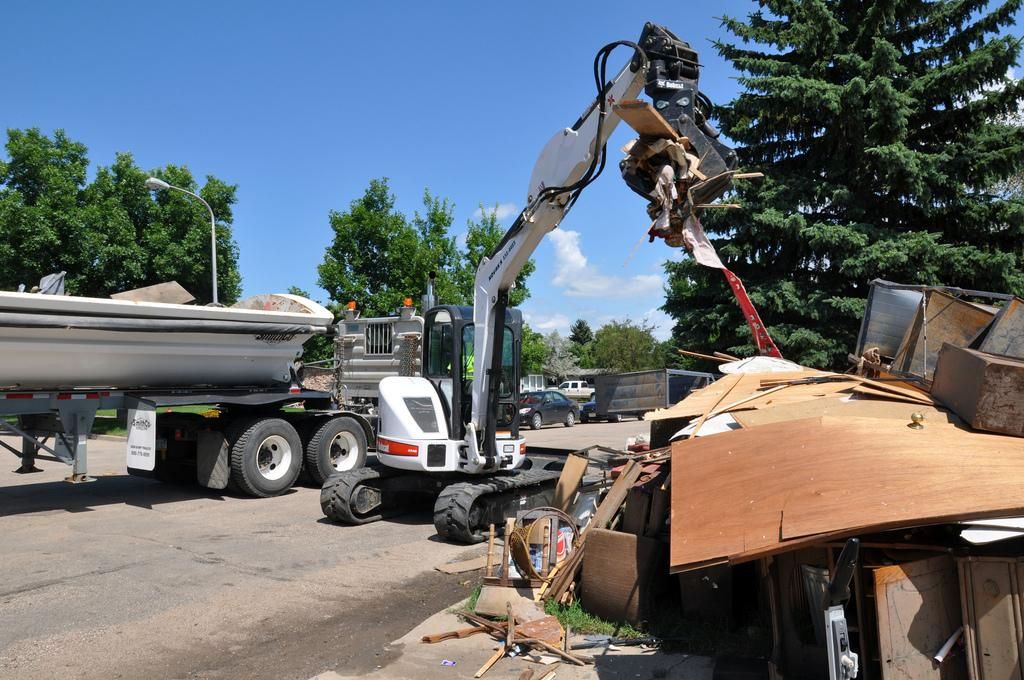What type of machinery is present in the image? There is a JCB in the image. What is the color of the JCB? The JCB is white in color. What is located beside the JCB? There is a vehicle beside the JCB. What can be seen on both sides of the JCB? There are trees on either side of the JCB. What is visible in the right corner of the image? There are other objects in the right corner of the image. How does the JCB react to the needle in the image? There is no needle present in the image, so the JCB does not react to it. 